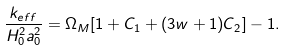Convert formula to latex. <formula><loc_0><loc_0><loc_500><loc_500>\frac { k _ { e f f } } { H _ { 0 } ^ { 2 } a _ { 0 } ^ { 2 } } = \Omega _ { M } [ 1 + C _ { 1 } + ( 3 w + 1 ) C _ { 2 } ] - 1 .</formula> 